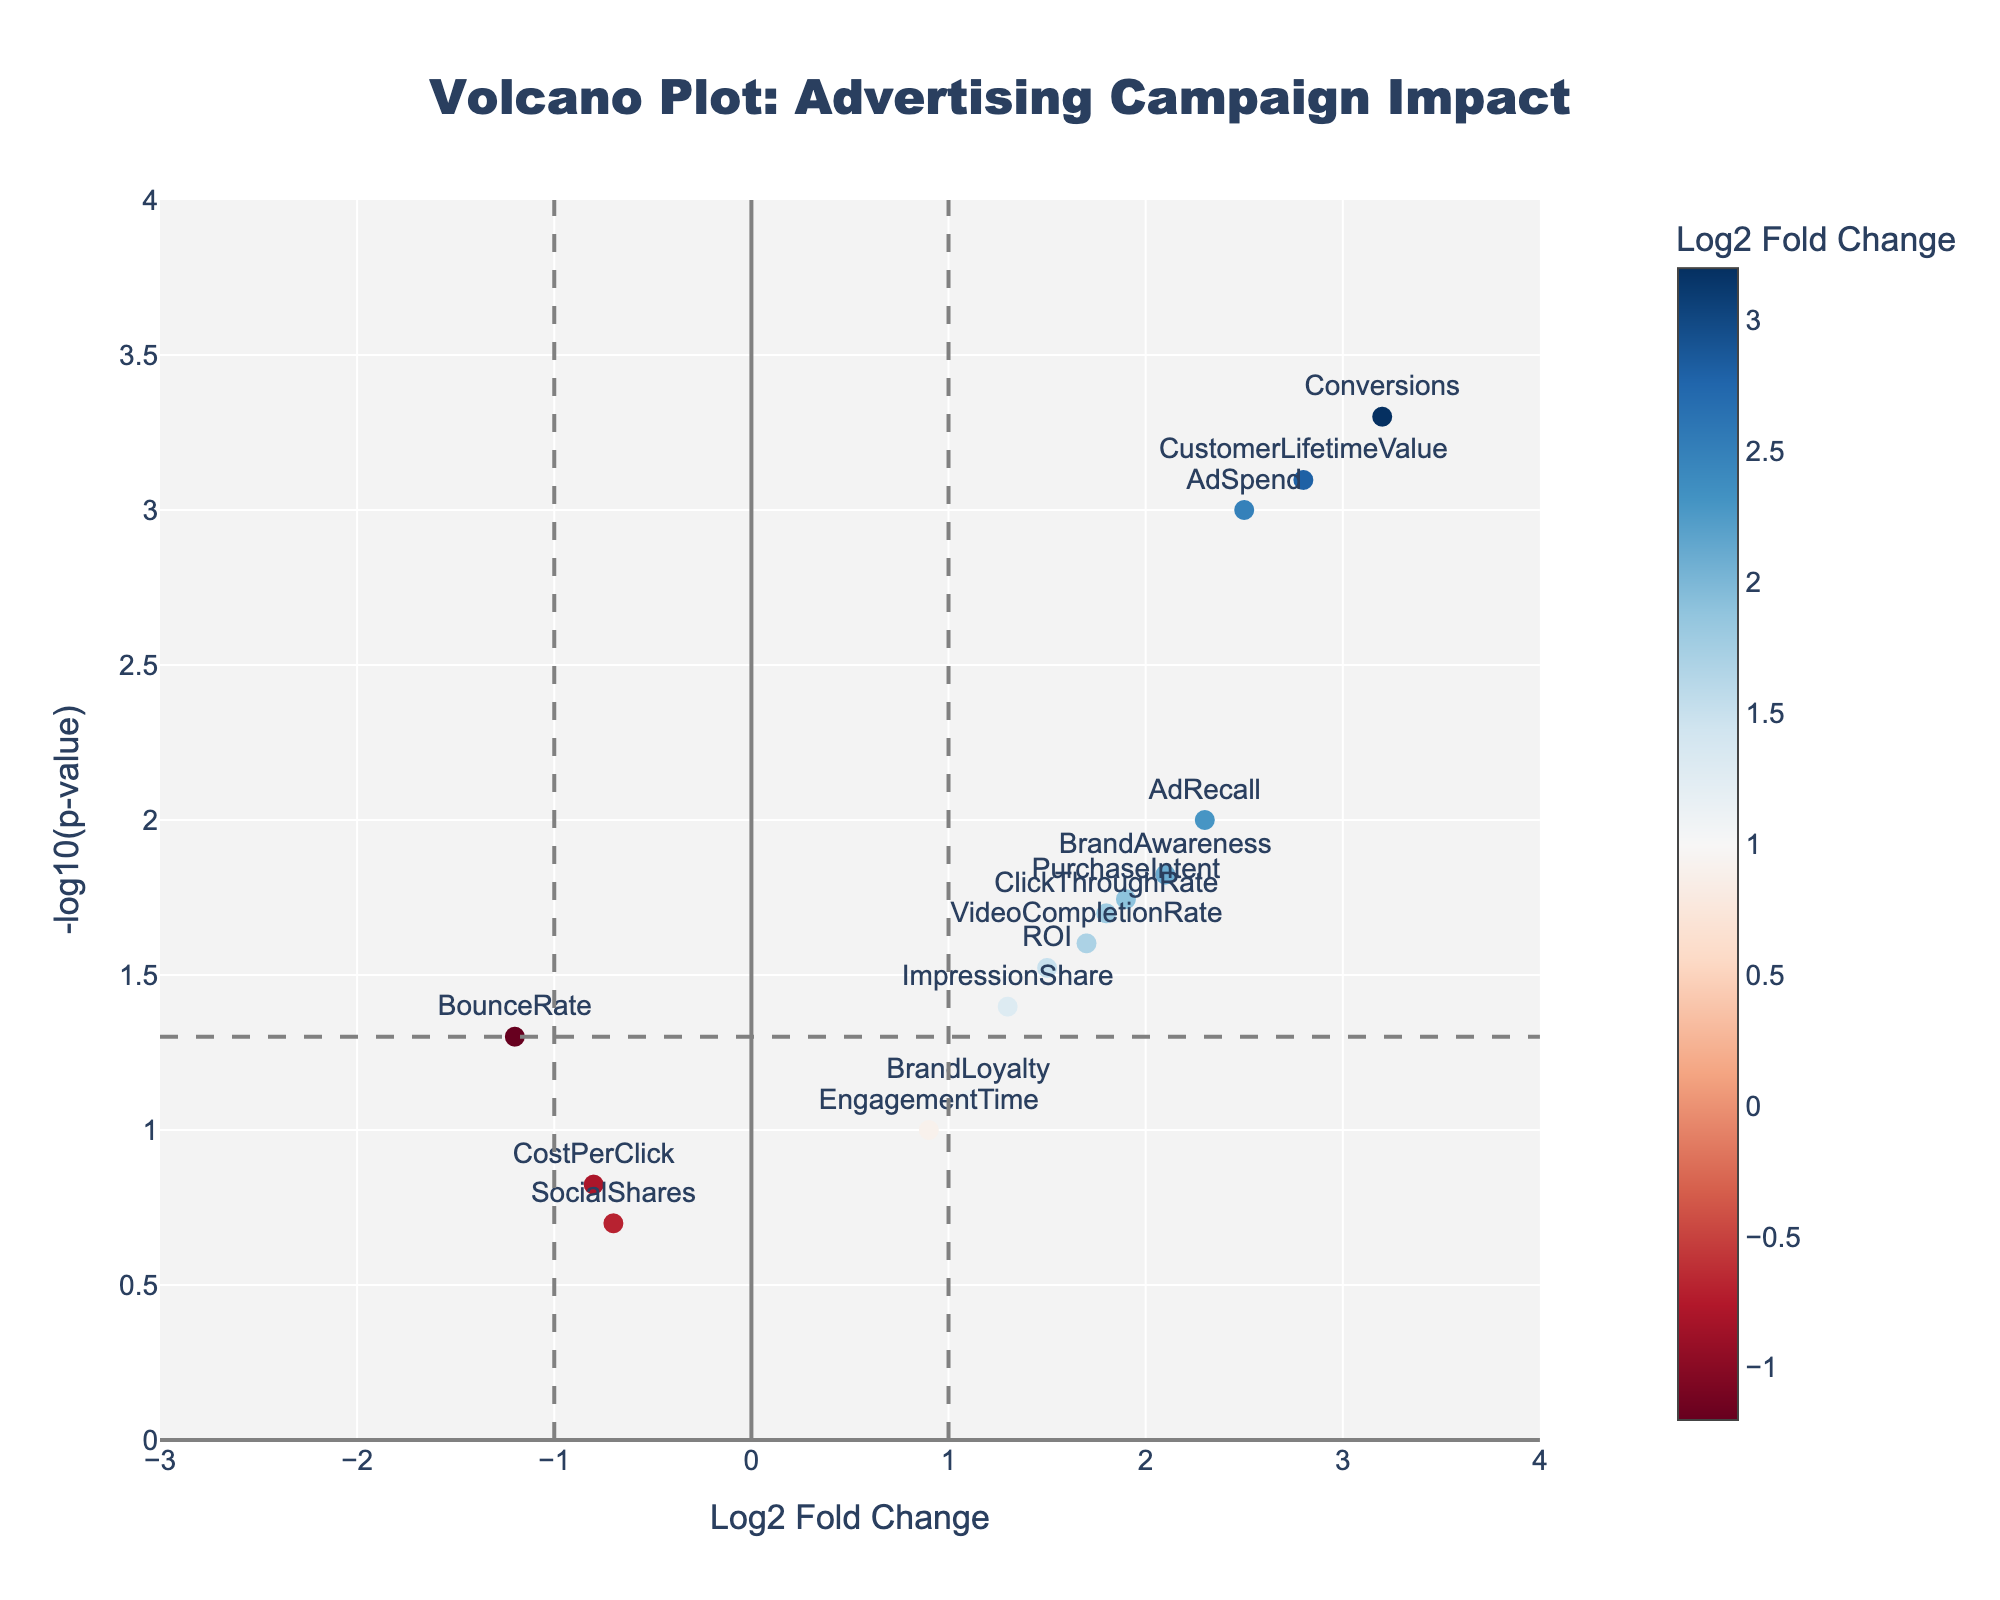How many data points (campaign metrics) are shown in the plot? By counting the number of unique markers in the plot, you can determine the number of data points.
Answer: 15 What is the title of the plot? The title is displayed at the top center of the plot.
Answer: Volcano Plot: Advertising Campaign Impact Which metric has the highest fold change? By identifying the metric with the highest x-value (Log2 Fold Change) in the positive direction, "Conversions" has the highest log2 fold change of 3.2.
Answer: Conversions Which metrics have a p-value less than 0.05? Metrics with -log10(p-value) above the horizontal grey dashed line (approximately y = 1.3) have p-values less than 0.05. These are "AdSpend," "ClickThroughRate," "Conversions," "BrandAwareness," "ROI," "ImpressionShare," "VideoCompletionRate," "CustomerLifetimeValue," "AdRecall," and "PurchaseIntent."
Answer: AdSpend, ClickThroughRate, Conversions, BrandAwareness, ROI, ImpressionShare, VideoCompletionRate, CustomerLifetimeValue, AdRecall, PurchaseIntent Which metric has the lowest statistical significance (highest p-value)? By identifying the metric with the lowest y-value (-log10(p-value)), "SocialShares" has the lowest statistical significance.
Answer: SocialShares How many metrics have a Log2 Fold Change greater than 1 and a p-value less than 0.05? Look for markers to the right of x = 1 and above the horizontal dashed line (y approximately 1.3). These metrics are "AdSpend," "Conversions," "BrandAwareness," "CustomerLifetimeValue," "AdRecall," and "PurchaseIntent." Count them.
Answer: 6 What does the vertical dashed line at x = -1 represent? It indicates the threshold for significant negative fold change, separating metrics with a Log2 Fold Change less than -1 from the others.
Answer: Threshold for significant negative fold change Between "AdRecall" and "PurchaseIntent," which metric shows higher statistical significance? Compare the y-values (-log10(p-value)) of "AdRecall" and "PurchaseIntent"; "AdRecall" is higher.
Answer: AdRecall Which metrics have a negative fold change? Metrics with Log2 Fold Change values less than 0 are "SocialShares," "BounceRate," and "CostPerClick."
Answer: SocialShares, BounceRate, CostPerClick How many metrics show both statistical significance (p-value < 0.05) and positive fold change? Look for markers with -log10(p-value) greater than 1.3 (p-value < 0.05) and Log2 Fold Change values greater than 0. These are "AdSpend," "Conversions," "BrandAwareness," "ImpressionShare," "VideoCompletionRate," "CustomerLifetimeValue," "AdRecall," and "PurchaseIntent." Count them.
Answer: 8 